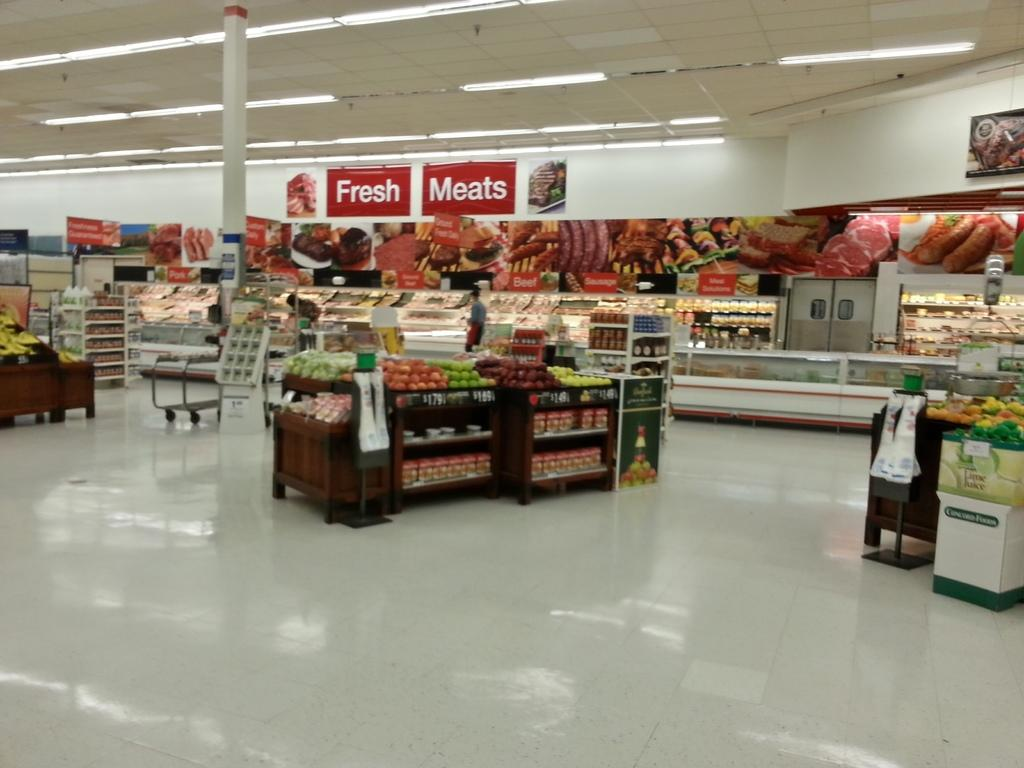Provide a one-sentence caption for the provided image. Inside a grocery store with a sign on the wall that says Fresh Meats and pictures of meats below it. 